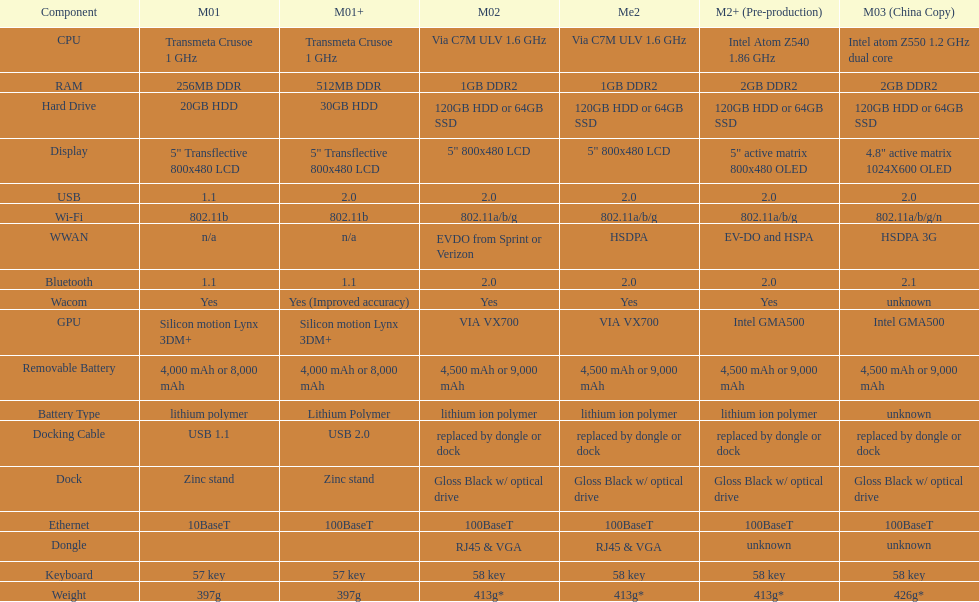Help me parse the entirety of this table. {'header': ['Component', 'M01', 'M01+', 'M02', 'Me2', 'M2+ (Pre-production)', 'M03 (China Copy)'], 'rows': [['CPU', 'Transmeta Crusoe 1\xa0GHz', 'Transmeta Crusoe 1\xa0GHz', 'Via C7M ULV 1.6\xa0GHz', 'Via C7M ULV 1.6\xa0GHz', 'Intel Atom Z540 1.86\xa0GHz', 'Intel atom Z550 1.2\xa0GHz dual core'], ['RAM', '256MB DDR', '512MB DDR', '1GB DDR2', '1GB DDR2', '2GB DDR2', '2GB DDR2'], ['Hard Drive', '20GB HDD', '30GB HDD', '120GB HDD or 64GB SSD', '120GB HDD or 64GB SSD', '120GB HDD or 64GB SSD', '120GB HDD or 64GB SSD'], ['Display', '5" Transflective 800x480 LCD', '5" Transflective 800x480 LCD', '5" 800x480 LCD', '5" 800x480 LCD', '5" active matrix 800x480 OLED', '4.8" active matrix 1024X600 OLED'], ['USB', '1.1', '2.0', '2.0', '2.0', '2.0', '2.0'], ['Wi-Fi', '802.11b', '802.11b', '802.11a/b/g', '802.11a/b/g', '802.11a/b/g', '802.11a/b/g/n'], ['WWAN', 'n/a', 'n/a', 'EVDO from Sprint or Verizon', 'HSDPA', 'EV-DO and HSPA', 'HSDPA 3G'], ['Bluetooth', '1.1', '1.1', '2.0', '2.0', '2.0', '2.1'], ['Wacom', 'Yes', 'Yes (Improved accuracy)', 'Yes', 'Yes', 'Yes', 'unknown'], ['GPU', 'Silicon motion Lynx 3DM+', 'Silicon motion Lynx 3DM+', 'VIA VX700', 'VIA VX700', 'Intel GMA500', 'Intel GMA500'], ['Removable Battery', '4,000 mAh or 8,000 mAh', '4,000 mAh or 8,000 mAh', '4,500 mAh or 9,000 mAh', '4,500 mAh or 9,000 mAh', '4,500 mAh or 9,000 mAh', '4,500 mAh or 9,000 mAh'], ['Battery Type', 'lithium polymer', 'Lithium Polymer', 'lithium ion polymer', 'lithium ion polymer', 'lithium ion polymer', 'unknown'], ['Docking Cable', 'USB 1.1', 'USB 2.0', 'replaced by dongle or dock', 'replaced by dongle or dock', 'replaced by dongle or dock', 'replaced by dongle or dock'], ['Dock', 'Zinc stand', 'Zinc stand', 'Gloss Black w/ optical drive', 'Gloss Black w/ optical drive', 'Gloss Black w/ optical drive', 'Gloss Black w/ optical drive'], ['Ethernet', '10BaseT', '100BaseT', '100BaseT', '100BaseT', '100BaseT', '100BaseT'], ['Dongle', '', '', 'RJ45 & VGA', 'RJ45 & VGA', 'unknown', 'unknown'], ['Keyboard', '57 key', '57 key', '58 key', '58 key', '58 key', '58 key'], ['Weight', '397g', '397g', '413g*', '413g*', '413g*', '426g*']]} What is the next highest hard drive available after the 30gb model? 64GB SSD. 